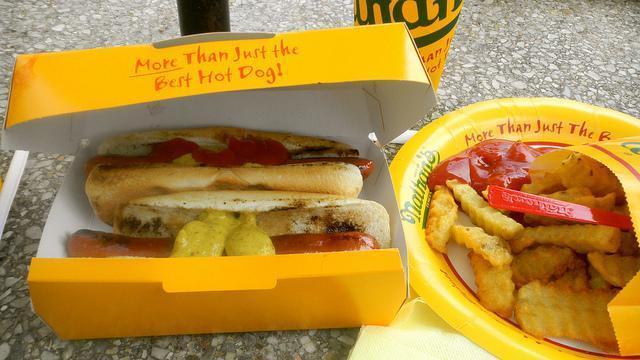How many hot dogs can be seen?
Give a very brief answer. 2. 